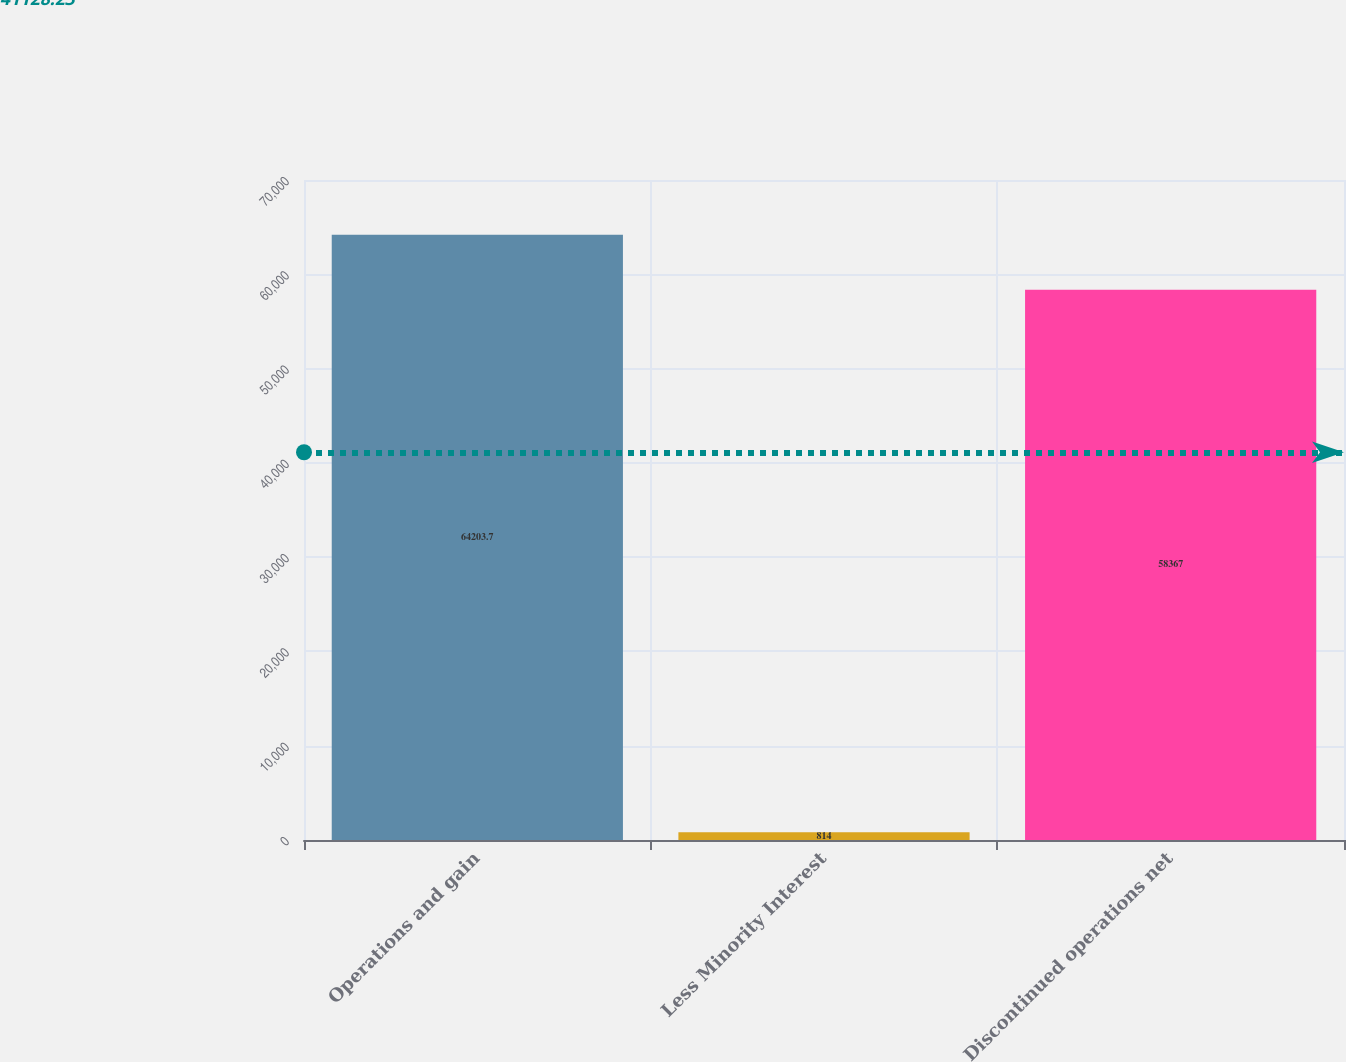Convert chart. <chart><loc_0><loc_0><loc_500><loc_500><bar_chart><fcel>Operations and gain<fcel>Less Minority Interest<fcel>Discontinued operations net<nl><fcel>64203.7<fcel>814<fcel>58367<nl></chart> 